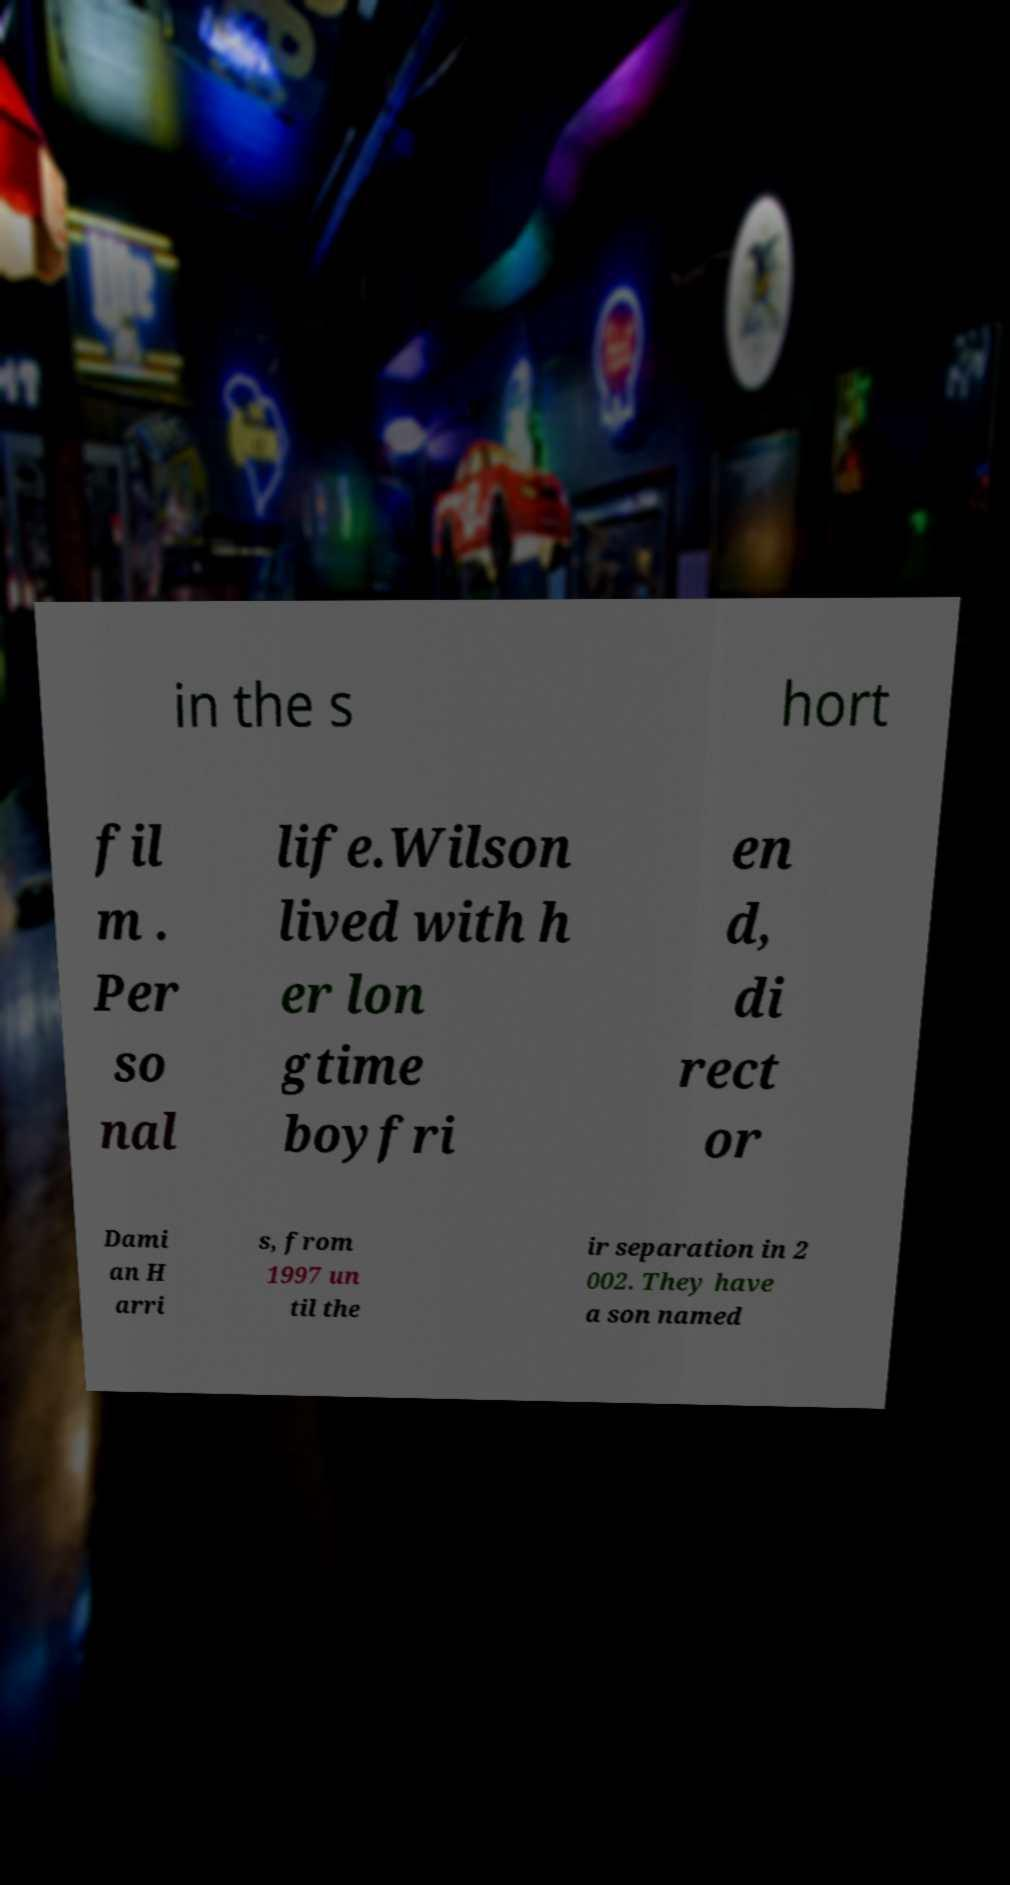Can you read and provide the text displayed in the image?This photo seems to have some interesting text. Can you extract and type it out for me? in the s hort fil m . Per so nal life.Wilson lived with h er lon gtime boyfri en d, di rect or Dami an H arri s, from 1997 un til the ir separation in 2 002. They have a son named 